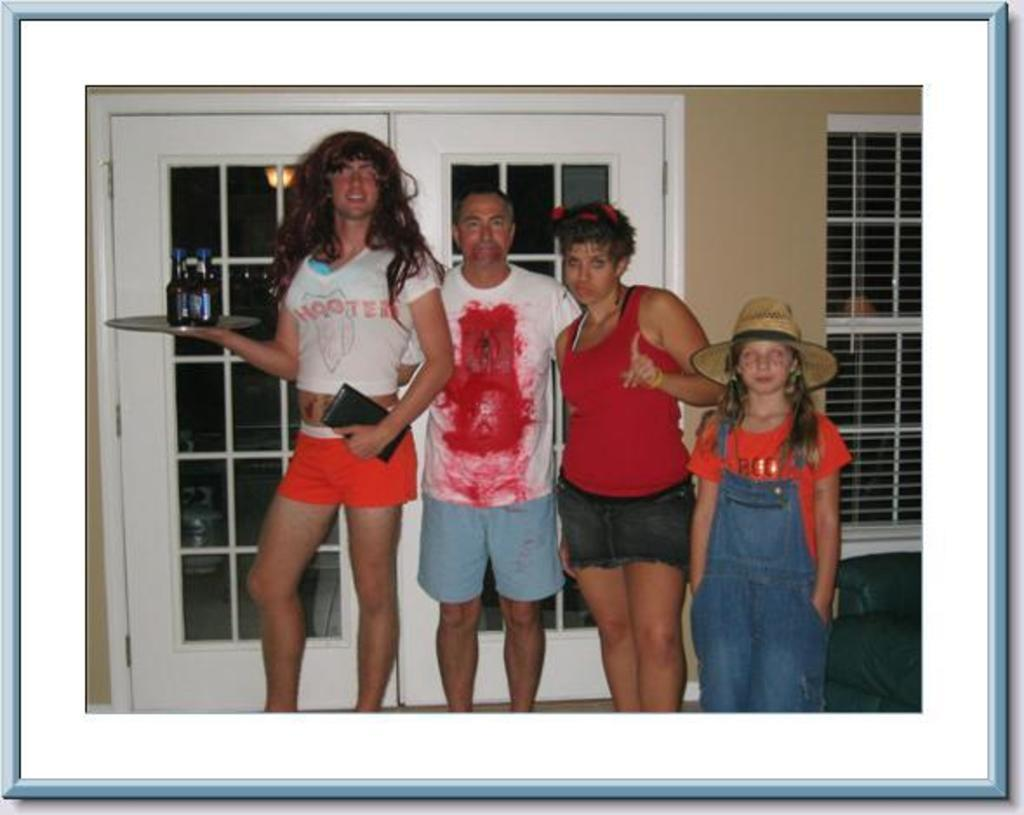Provide a one-sentence caption for the provided image. a family photo where one guy is wearing aHooters outfit. 